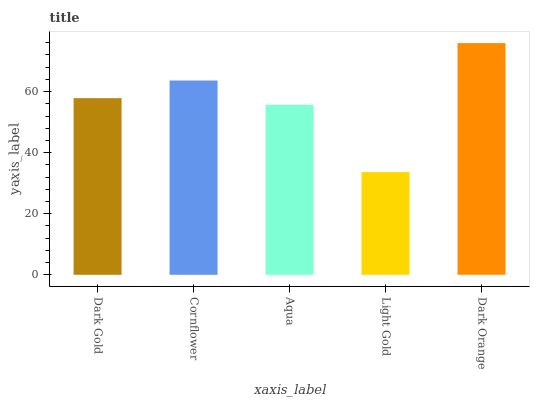Is Light Gold the minimum?
Answer yes or no. Yes. Is Dark Orange the maximum?
Answer yes or no. Yes. Is Cornflower the minimum?
Answer yes or no. No. Is Cornflower the maximum?
Answer yes or no. No. Is Cornflower greater than Dark Gold?
Answer yes or no. Yes. Is Dark Gold less than Cornflower?
Answer yes or no. Yes. Is Dark Gold greater than Cornflower?
Answer yes or no. No. Is Cornflower less than Dark Gold?
Answer yes or no. No. Is Dark Gold the high median?
Answer yes or no. Yes. Is Dark Gold the low median?
Answer yes or no. Yes. Is Cornflower the high median?
Answer yes or no. No. Is Aqua the low median?
Answer yes or no. No. 